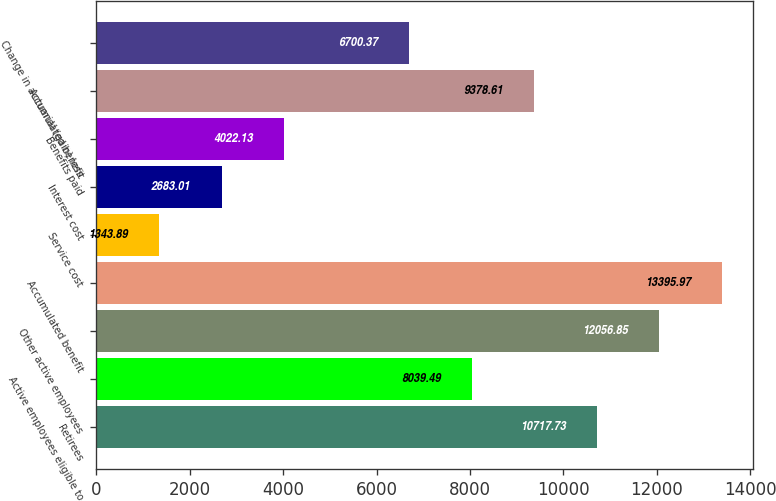Convert chart to OTSL. <chart><loc_0><loc_0><loc_500><loc_500><bar_chart><fcel>Retirees<fcel>Active employees eligible to<fcel>Other active employees<fcel>Accumulated benefit<fcel>Service cost<fcel>Interest cost<fcel>Benefits paid<fcel>Actuarial (gain) loss<fcel>Change in accumulated benefit<nl><fcel>10717.7<fcel>8039.49<fcel>12056.9<fcel>13396<fcel>1343.89<fcel>2683.01<fcel>4022.13<fcel>9378.61<fcel>6700.37<nl></chart> 